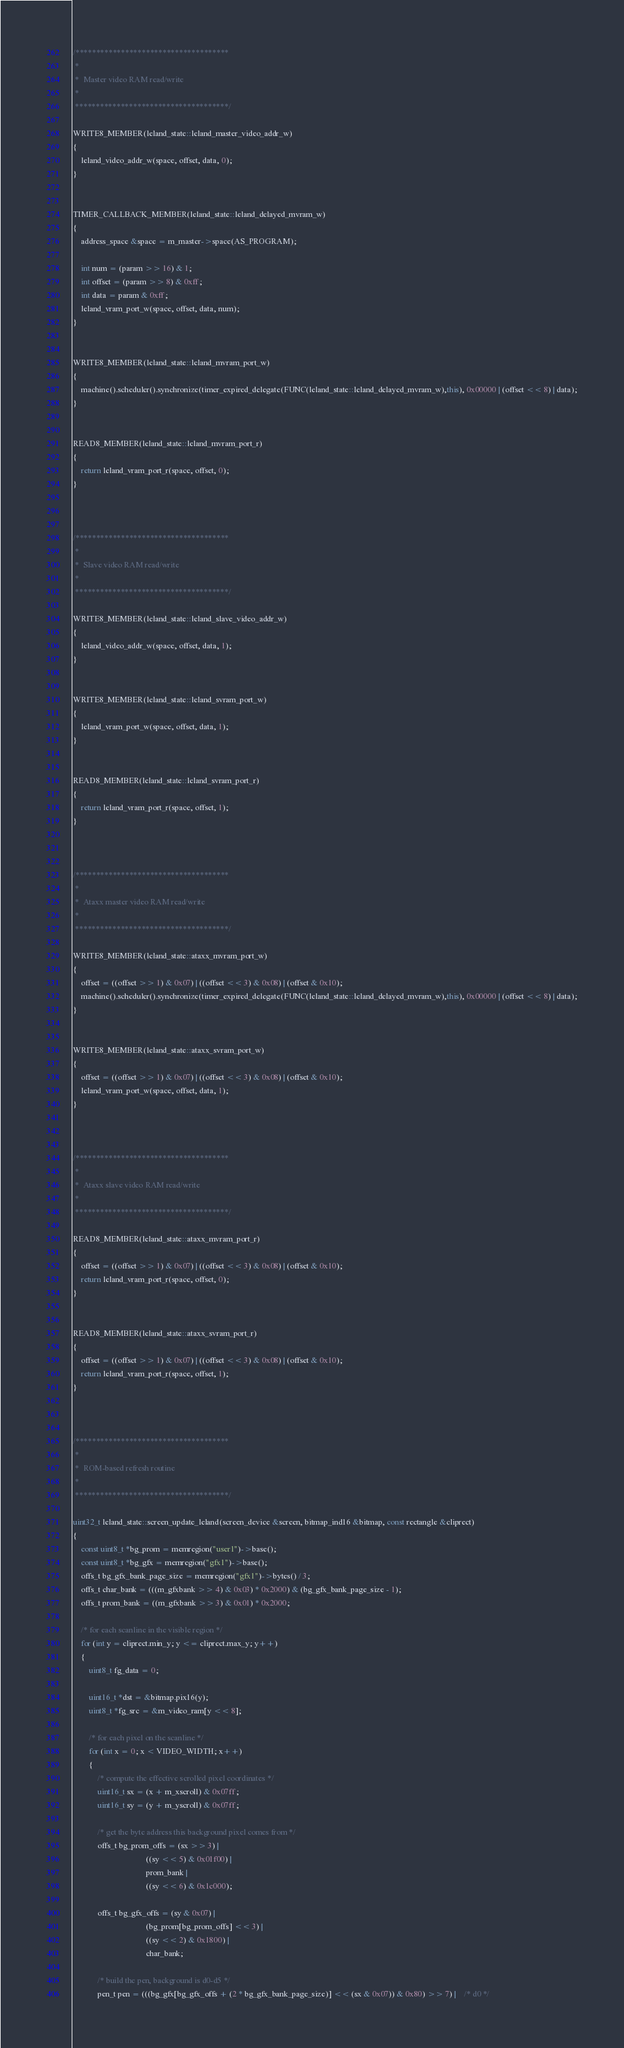<code> <loc_0><loc_0><loc_500><loc_500><_C++_>


/*************************************
 *
 *  Master video RAM read/write
 *
 *************************************/

WRITE8_MEMBER(leland_state::leland_master_video_addr_w)
{
	leland_video_addr_w(space, offset, data, 0);
}


TIMER_CALLBACK_MEMBER(leland_state::leland_delayed_mvram_w)
{
	address_space &space = m_master->space(AS_PROGRAM);

	int num = (param >> 16) & 1;
	int offset = (param >> 8) & 0xff;
	int data = param & 0xff;
	leland_vram_port_w(space, offset, data, num);
}


WRITE8_MEMBER(leland_state::leland_mvram_port_w)
{
	machine().scheduler().synchronize(timer_expired_delegate(FUNC(leland_state::leland_delayed_mvram_w),this), 0x00000 | (offset << 8) | data);
}


READ8_MEMBER(leland_state::leland_mvram_port_r)
{
	return leland_vram_port_r(space, offset, 0);
}



/*************************************
 *
 *  Slave video RAM read/write
 *
 *************************************/

WRITE8_MEMBER(leland_state::leland_slave_video_addr_w)
{
	leland_video_addr_w(space, offset, data, 1);
}


WRITE8_MEMBER(leland_state::leland_svram_port_w)
{
	leland_vram_port_w(space, offset, data, 1);
}


READ8_MEMBER(leland_state::leland_svram_port_r)
{
	return leland_vram_port_r(space, offset, 1);
}



/*************************************
 *
 *  Ataxx master video RAM read/write
 *
 *************************************/

WRITE8_MEMBER(leland_state::ataxx_mvram_port_w)
{
	offset = ((offset >> 1) & 0x07) | ((offset << 3) & 0x08) | (offset & 0x10);
	machine().scheduler().synchronize(timer_expired_delegate(FUNC(leland_state::leland_delayed_mvram_w),this), 0x00000 | (offset << 8) | data);
}


WRITE8_MEMBER(leland_state::ataxx_svram_port_w)
{
	offset = ((offset >> 1) & 0x07) | ((offset << 3) & 0x08) | (offset & 0x10);
	leland_vram_port_w(space, offset, data, 1);
}



/*************************************
 *
 *  Ataxx slave video RAM read/write
 *
 *************************************/

READ8_MEMBER(leland_state::ataxx_mvram_port_r)
{
	offset = ((offset >> 1) & 0x07) | ((offset << 3) & 0x08) | (offset & 0x10);
	return leland_vram_port_r(space, offset, 0);
}


READ8_MEMBER(leland_state::ataxx_svram_port_r)
{
	offset = ((offset >> 1) & 0x07) | ((offset << 3) & 0x08) | (offset & 0x10);
	return leland_vram_port_r(space, offset, 1);
}



/*************************************
 *
 *  ROM-based refresh routine
 *
 *************************************/

uint32_t leland_state::screen_update_leland(screen_device &screen, bitmap_ind16 &bitmap, const rectangle &cliprect)
{
	const uint8_t *bg_prom = memregion("user1")->base();
	const uint8_t *bg_gfx = memregion("gfx1")->base();
	offs_t bg_gfx_bank_page_size = memregion("gfx1")->bytes() / 3;
	offs_t char_bank = (((m_gfxbank >> 4) & 0x03) * 0x2000) & (bg_gfx_bank_page_size - 1);
	offs_t prom_bank = ((m_gfxbank >> 3) & 0x01) * 0x2000;

	/* for each scanline in the visible region */
	for (int y = cliprect.min_y; y <= cliprect.max_y; y++)
	{
		uint8_t fg_data = 0;

		uint16_t *dst = &bitmap.pix16(y);
		uint8_t *fg_src = &m_video_ram[y << 8];

		/* for each pixel on the scanline */
		for (int x = 0; x < VIDEO_WIDTH; x++)
		{
			/* compute the effective scrolled pixel coordinates */
			uint16_t sx = (x + m_xscroll) & 0x07ff;
			uint16_t sy = (y + m_yscroll) & 0x07ff;

			/* get the byte address this background pixel comes from */
			offs_t bg_prom_offs = (sx >> 3) |
									((sy << 5) & 0x01f00) |
									prom_bank |
									((sy << 6) & 0x1c000);

			offs_t bg_gfx_offs = (sy & 0x07) |
									(bg_prom[bg_prom_offs] << 3) |
									((sy << 2) & 0x1800) |
									char_bank;

			/* build the pen, background is d0-d5 */
			pen_t pen = (((bg_gfx[bg_gfx_offs + (2 * bg_gfx_bank_page_size)] << (sx & 0x07)) & 0x80) >> 7) |    /* d0 */</code> 